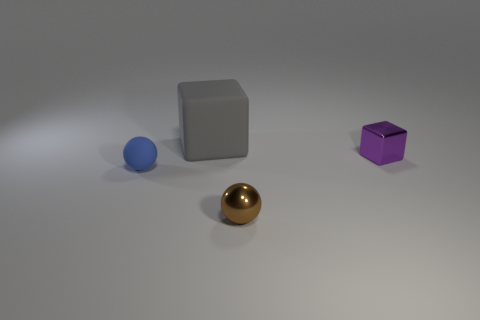Add 4 blue matte spheres. How many objects exist? 8 Subtract all purple blocks. How many blocks are left? 1 Subtract all matte objects. Subtract all tiny cubes. How many objects are left? 1 Add 4 shiny spheres. How many shiny spheres are left? 5 Add 3 purple metal cylinders. How many purple metal cylinders exist? 3 Subtract 1 purple blocks. How many objects are left? 3 Subtract all green balls. Subtract all red blocks. How many balls are left? 2 